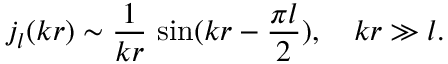<formula> <loc_0><loc_0><loc_500><loc_500>j _ { l } ( k r ) \sim \frac { 1 } { k r } \, \sin ( k r - \frac { \pi l } { 2 } ) , \quad k r \gg l .</formula> 